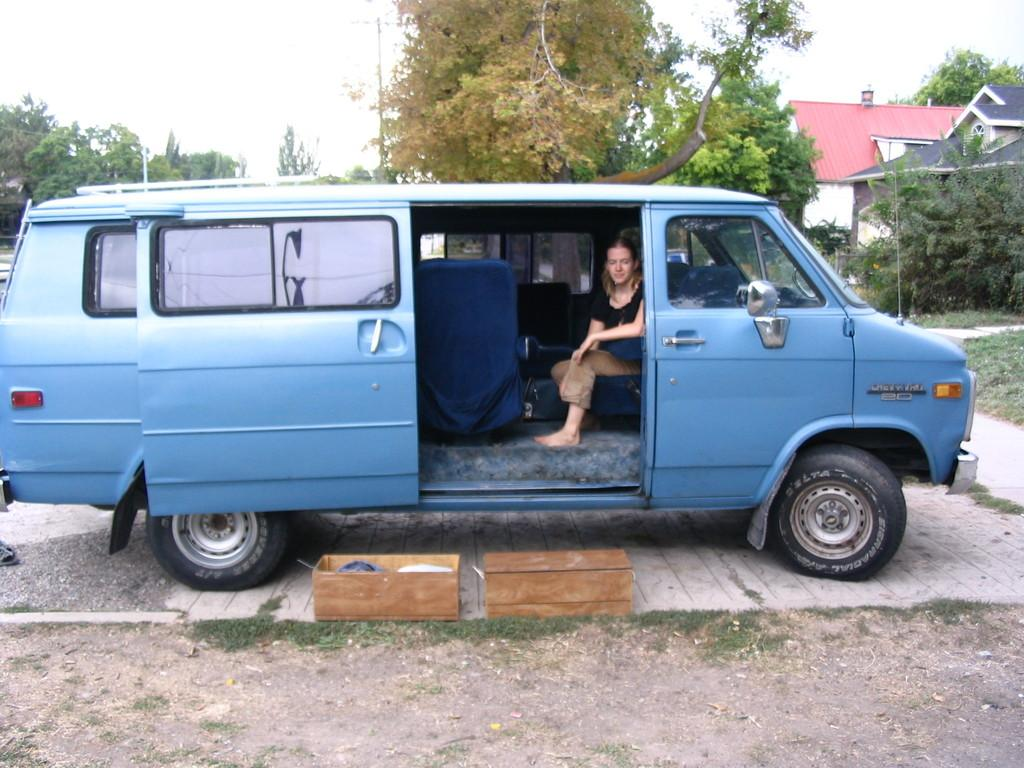What is the woman in the image doing? The woman is seated in the car. What objects are in front of the woman? There are two boxes in front of the woman. What can be seen in the background of the image? Trees and buildings are visible in the background. Can you see a snail crawling on the woman's shoulder in the image? No, there is no snail visible in the image. 